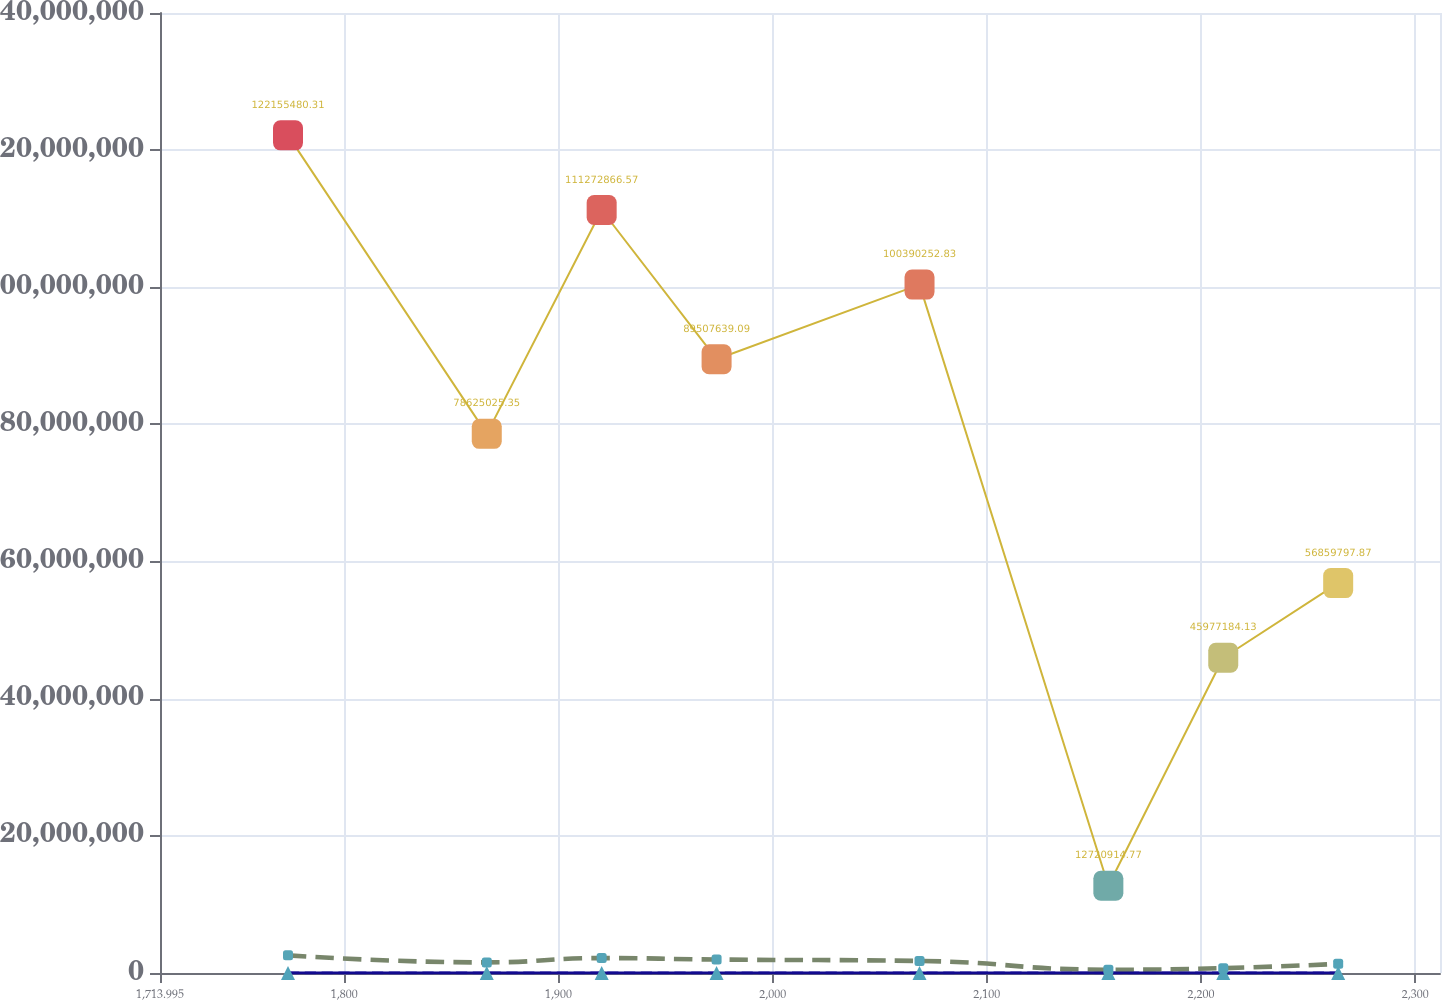Convert chart. <chart><loc_0><loc_0><loc_500><loc_500><line_chart><ecel><fcel>2.2  %<fcel>273,000<fcel>$  40.00<fcel>$ 10,920,000<nl><fcel>1773.75<fcel>261.05<fcel>2.57635e+06<fcel>24.39<fcel>1.22155e+08<nl><fcel>1866.54<fcel>212.72<fcel>1.54534e+06<fcel>16.15<fcel>7.8625e+07<nl><fcel>1920.18<fcel>188.57<fcel>2.17365e+06<fcel>20.25<fcel>1.11273e+08<nl><fcel>1973.83<fcel>164.42<fcel>1.96421e+06<fcel>18.2<fcel>8.95076e+07<nl><fcel>2068.57<fcel>140.27<fcel>1.75478e+06<fcel>14.1<fcel>1.0039e+08<nl><fcel>2156.72<fcel>67.82<fcel>481990<fcel>3.85<fcel>1.27209e+07<nl><fcel>2210.36<fcel>116.12<fcel>707594<fcel>7.95<fcel>4.59772e+07<nl><fcel>2264.01<fcel>91.97<fcel>1.3359e+06<fcel>10<fcel>5.68598e+07<nl><fcel>2317.66<fcel>43.67<fcel>917030<fcel>5.9<fcel>3.50946e+07<nl><fcel>2371.3<fcel>19.52<fcel>1.12647e+06<fcel>12.05<fcel>6.77424e+07<nl></chart> 